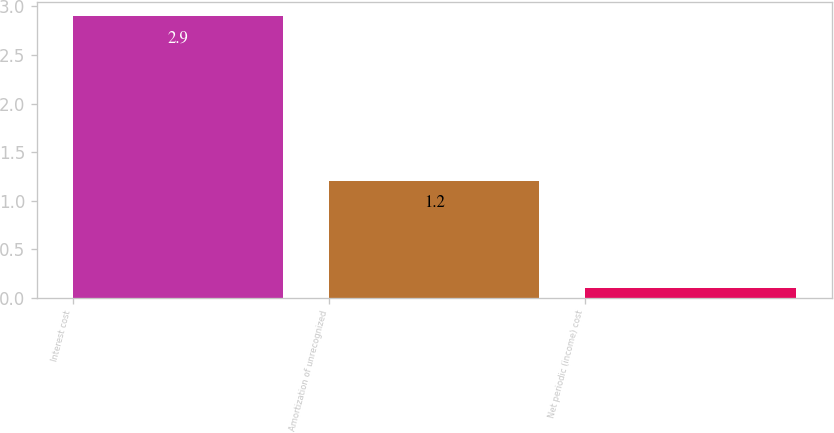Convert chart. <chart><loc_0><loc_0><loc_500><loc_500><bar_chart><fcel>Interest cost<fcel>Amortization of unrecognized<fcel>Net periodic (income) cost<nl><fcel>2.9<fcel>1.2<fcel>0.1<nl></chart> 